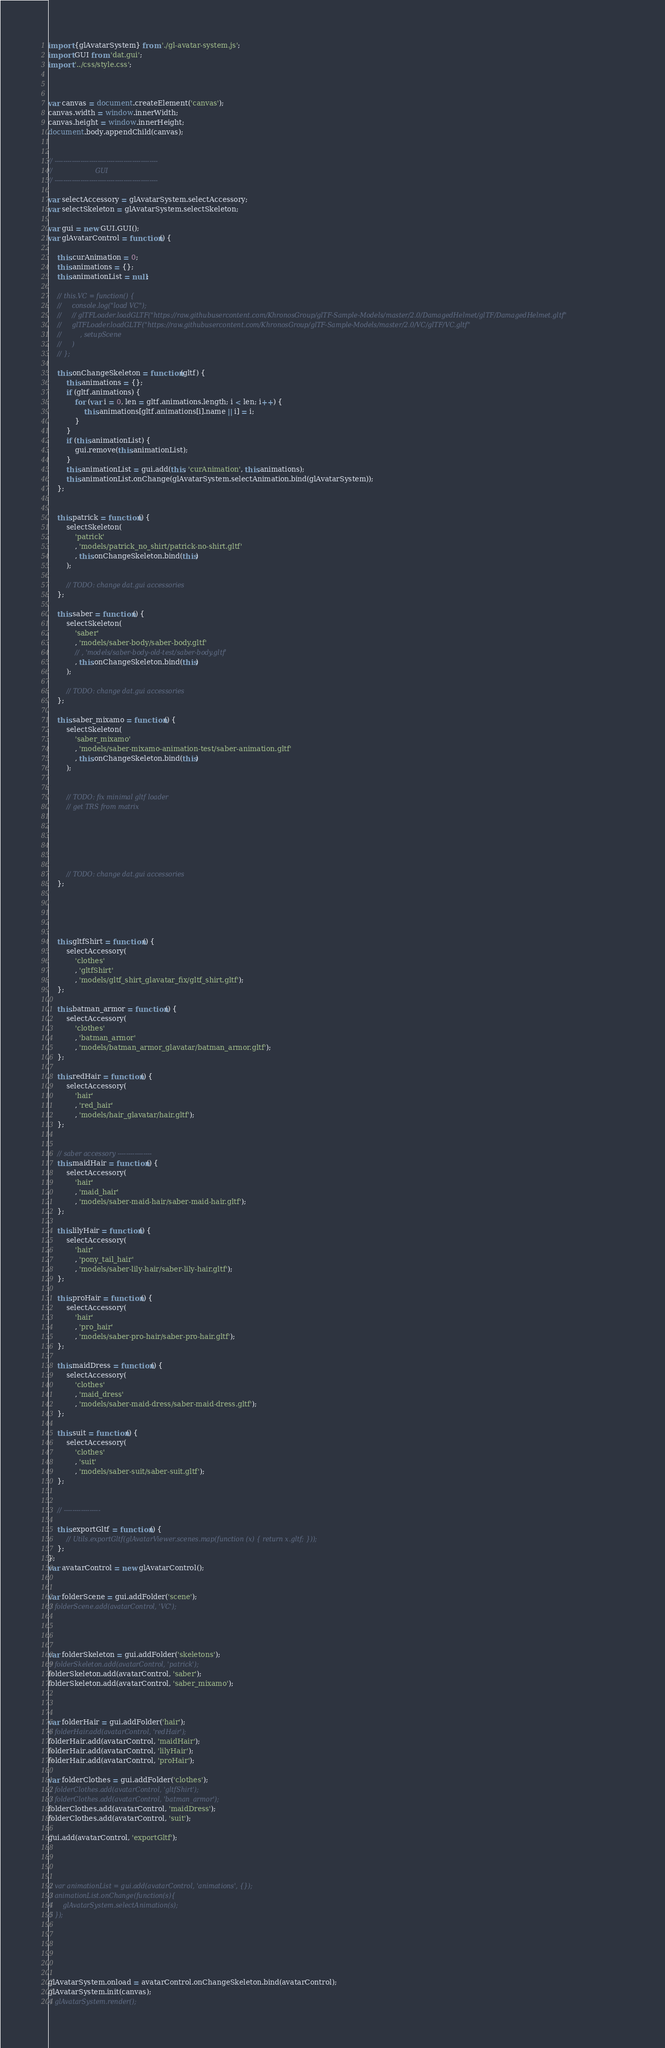<code> <loc_0><loc_0><loc_500><loc_500><_JavaScript_>


import {glAvatarSystem} from './gl-avatar-system.js';
import GUI from 'dat.gui';
import '../css/style.css';



var canvas = document.createElement('canvas');
canvas.width = window.innerWidth;
canvas.height = window.innerHeight;
document.body.appendChild(canvas);


// ------------------------------------------------
//                     GUI
// ------------------------------------------------

var selectAccessory = glAvatarSystem.selectAccessory;
var selectSkeleton = glAvatarSystem.selectSkeleton;

var gui = new GUI.GUI();
var glAvatarControl = function() {

    this.curAnimation = 0;
    this.animations = {};
    this.animationList = null;

    // this.VC = function() {
    //     console.log("load VC");
    //     // glTFLoader.loadGLTF("https://raw.githubusercontent.com/KhronosGroup/glTF-Sample-Models/master/2.0/DamagedHelmet/glTF/DamagedHelmet.gltf"
    //     glTFLoader.loadGLTF("https://raw.githubusercontent.com/KhronosGroup/glTF-Sample-Models/master/2.0/VC/glTF/VC.gltf"
    //         , setupScene
    //     )
    // };
    
    this.onChangeSkeleton = function(gltf) {
        this.animations = {};
        if (gltf.animations) {
            for (var i = 0, len = gltf.animations.length; i < len; i++) {
                this.animations[gltf.animations[i].name || i] = i;
            }
        }
        if (this.animationList) {
            gui.remove(this.animationList);
        }
        this.animationList = gui.add(this, 'curAnimation', this.animations);
        this.animationList.onChange(glAvatarSystem.selectAnimation.bind(glAvatarSystem));
    };


    this.patrick = function() {
        selectSkeleton(
            'patrick'
            , 'models/patrick_no_shirt/patrick-no-shirt.gltf'
            , this.onChangeSkeleton.bind(this)
        );

        // TODO: change dat.gui accessories
    };

    this.saber = function() {
        selectSkeleton(
            'saber'
            , 'models/saber-body/saber-body.gltf'
            // , 'models/saber-body-old-test/saber-body.gltf'
            , this.onChangeSkeleton.bind(this)
        );

        // TODO: change dat.gui accessories
    };

    this.saber_mixamo = function() {
        selectSkeleton(
            'saber_mixamo'
            , 'models/saber-mixamo-animation-test/saber-animation.gltf'
            , this.onChangeSkeleton.bind(this)
        );


        // TODO: fix minimal gltf loader 
        // get TRS from matrix
        





        // TODO: change dat.gui accessories
    };





    this.gltfShirt = function() {
        selectAccessory(
            'clothes'
            , 'gltfShirt'
            , 'models/gltf_shirt_glavatar_fix/gltf_shirt.gltf');
    };

    this.batman_armor = function() {
        selectAccessory(
            'clothes'
            , 'batman_armor'
            , 'models/batman_armor_glavatar/batman_armor.gltf');
    };

    this.redHair = function() {
        selectAccessory(
            'hair'
            , 'red_hair'
            , 'models/hair_glavatar/hair.gltf');
    };


    // saber accessory ----------------
    this.maidHair = function() {
        selectAccessory(
            'hair'
            , 'maid_hair'
            , 'models/saber-maid-hair/saber-maid-hair.gltf');
    };

    this.lilyHair = function() {
        selectAccessory(
            'hair'
            , 'pony_tail_hair'
            , 'models/saber-lily-hair/saber-lily-hair.gltf');
    };

    this.proHair = function() {
        selectAccessory(
            'hair'
            , 'pro_hair'
            , 'models/saber-pro-hair/saber-pro-hair.gltf');
    };

    this.maidDress = function() {
        selectAccessory(
            'clothes'
            , 'maid_dress'
            , 'models/saber-maid-dress/saber-maid-dress.gltf');
    };

    this.suit = function() {
        selectAccessory(
            'clothes'
            , 'suit'
            , 'models/saber-suit/saber-suit.gltf');
    };


    // -----------------

    this.exportGltf = function() {
        // Utils.exportGltf(glAvatarViewer.scenes.map(function (x) { return x.gltf; }));
    };
};
var avatarControl = new glAvatarControl();


var folderScene = gui.addFolder('scene');
// folderScene.add(avatarControl, 'VC');




var folderSkeleton = gui.addFolder('skeletons');
// folderSkeleton.add(avatarControl, 'patrick');
folderSkeleton.add(avatarControl, 'saber');
folderSkeleton.add(avatarControl, 'saber_mixamo');



var folderHair = gui.addFolder('hair');
// folderHair.add(avatarControl, 'redHair');
folderHair.add(avatarControl, 'maidHair');
folderHair.add(avatarControl, 'lilyHair');
folderHair.add(avatarControl, 'proHair');

var folderClothes = gui.addFolder('clothes');
// folderClothes.add(avatarControl, 'gltfShirt');
// folderClothes.add(avatarControl, 'batman_armor');
folderClothes.add(avatarControl, 'maidDress');
folderClothes.add(avatarControl, 'suit');

gui.add(avatarControl, 'exportGltf');




// var animationList = gui.add(avatarControl, 'animations', {});
// animationList.onChange(function(s){
//     glAvatarSystem.selectAnimation(s);
// });






glAvatarSystem.onload = avatarControl.onChangeSkeleton.bind(avatarControl);
glAvatarSystem.init(canvas);
// glAvatarSystem.render();
</code> 